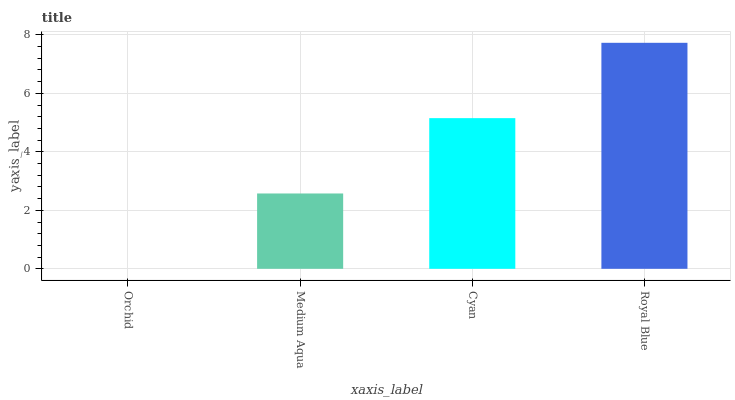Is Orchid the minimum?
Answer yes or no. Yes. Is Royal Blue the maximum?
Answer yes or no. Yes. Is Medium Aqua the minimum?
Answer yes or no. No. Is Medium Aqua the maximum?
Answer yes or no. No. Is Medium Aqua greater than Orchid?
Answer yes or no. Yes. Is Orchid less than Medium Aqua?
Answer yes or no. Yes. Is Orchid greater than Medium Aqua?
Answer yes or no. No. Is Medium Aqua less than Orchid?
Answer yes or no. No. Is Cyan the high median?
Answer yes or no. Yes. Is Medium Aqua the low median?
Answer yes or no. Yes. Is Royal Blue the high median?
Answer yes or no. No. Is Royal Blue the low median?
Answer yes or no. No. 